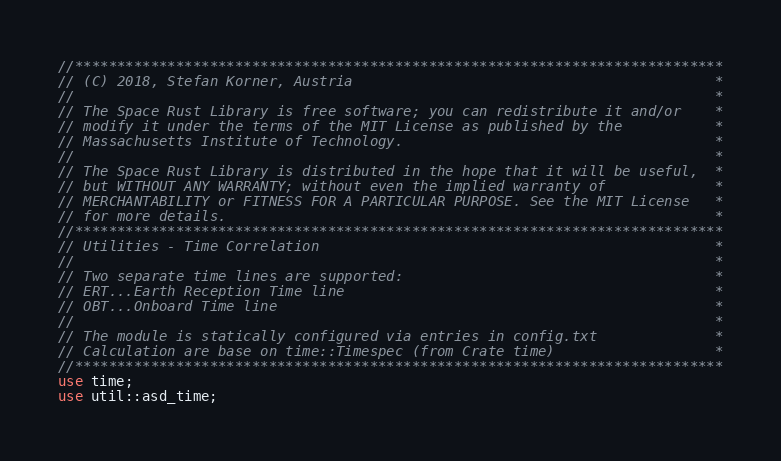Convert code to text. <code><loc_0><loc_0><loc_500><loc_500><_Rust_>//*****************************************************************************
// (C) 2018, Stefan Korner, Austria                                           *
//                                                                            *
// The Space Rust Library is free software; you can redistribute it and/or    *
// modify it under the terms of the MIT License as published by the           *
// Massachusetts Institute of Technology.                                     *
//                                                                            *
// The Space Rust Library is distributed in the hope that it will be useful,  *
// but WITHOUT ANY WARRANTY; without even the implied warranty of             *
// MERCHANTABILITY or FITNESS FOR A PARTICULAR PURPOSE. See the MIT License   *
// for more details.                                                          *
//*****************************************************************************
// Utilities - Time Correlation                                               *
//                                                                            *
// Two separate time lines are supported:                                     *
// ERT...Earth Reception Time line                                            *
// OBT...Onboard Time line                                                    *
//                                                                            *
// The module is statically configured via entries in config.txt              *
// Calculation are base on time::Timespec (from Crate time)                   *
//*****************************************************************************
use time;
use util::asd_time;</code> 